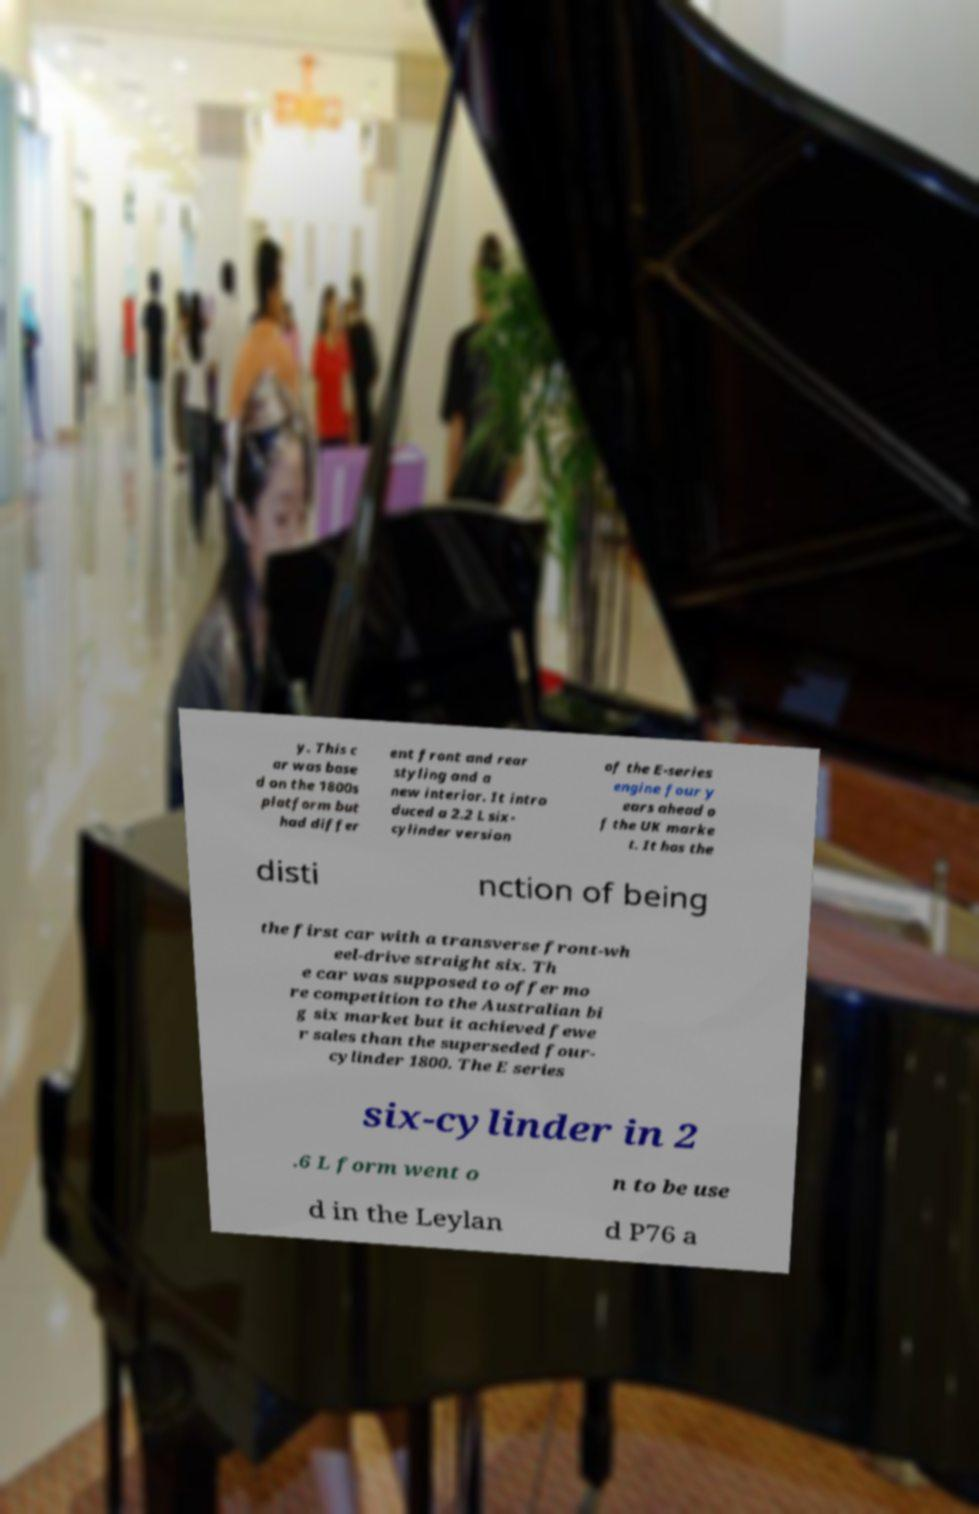I need the written content from this picture converted into text. Can you do that? y. This c ar was base d on the 1800s platform but had differ ent front and rear styling and a new interior. It intro duced a 2.2 L six- cylinder version of the E-series engine four y ears ahead o f the UK marke t. It has the disti nction of being the first car with a transverse front-wh eel-drive straight six. Th e car was supposed to offer mo re competition to the Australian bi g six market but it achieved fewe r sales than the superseded four- cylinder 1800. The E series six-cylinder in 2 .6 L form went o n to be use d in the Leylan d P76 a 